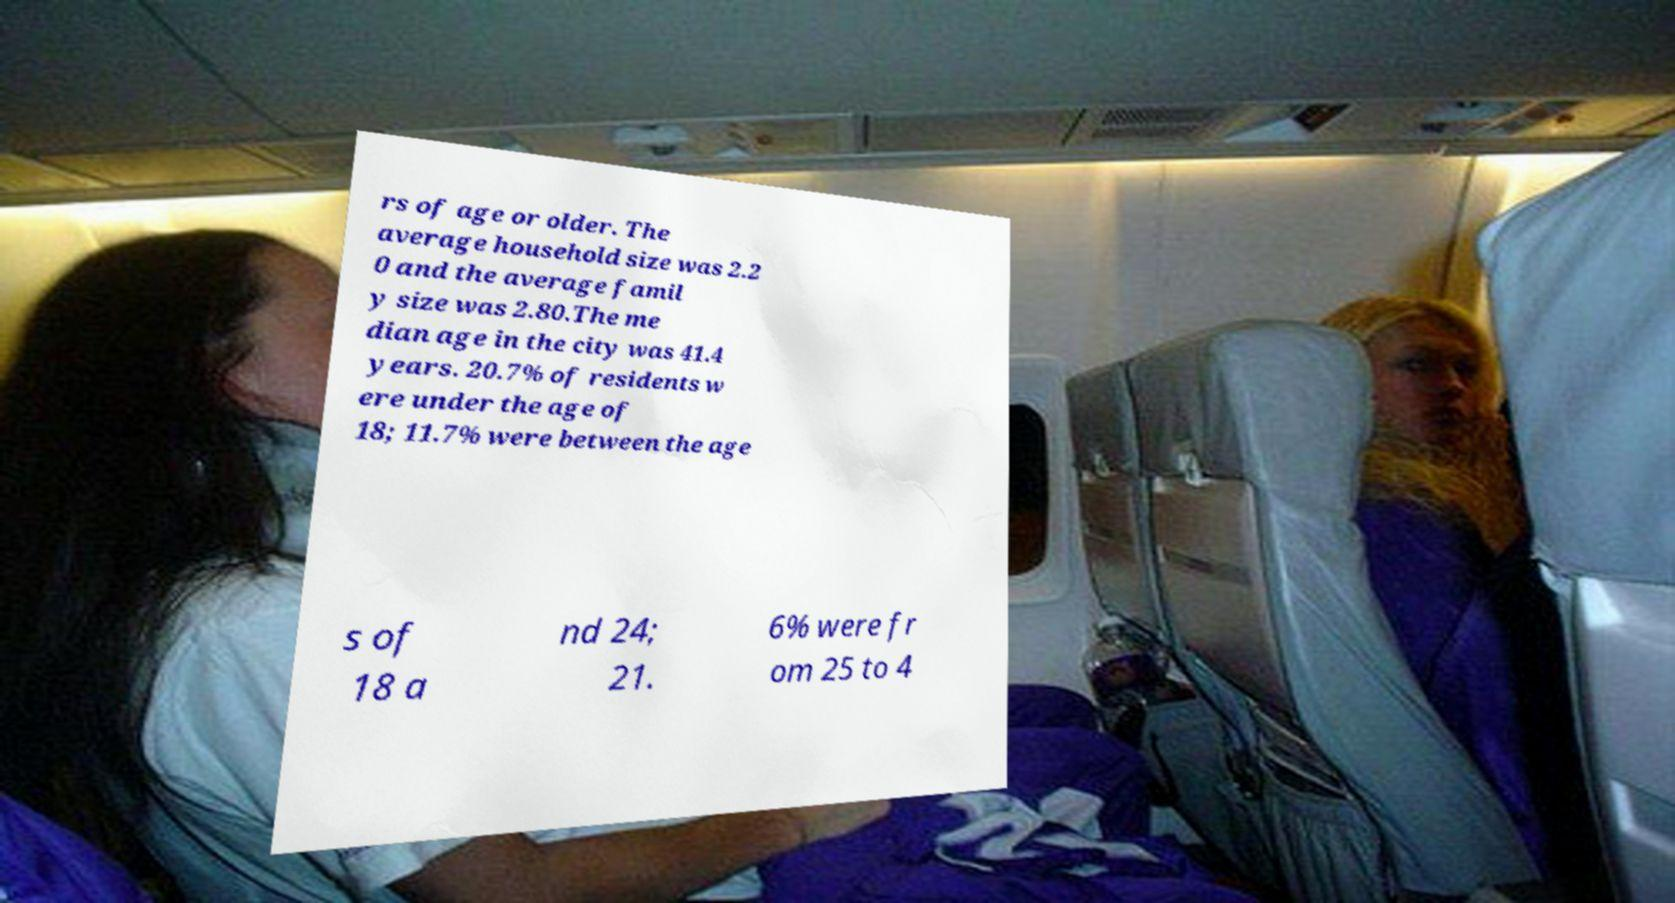Please identify and transcribe the text found in this image. rs of age or older. The average household size was 2.2 0 and the average famil y size was 2.80.The me dian age in the city was 41.4 years. 20.7% of residents w ere under the age of 18; 11.7% were between the age s of 18 a nd 24; 21. 6% were fr om 25 to 4 